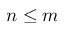Convert formula to latex. <formula><loc_0><loc_0><loc_500><loc_500>n \leq m</formula> 